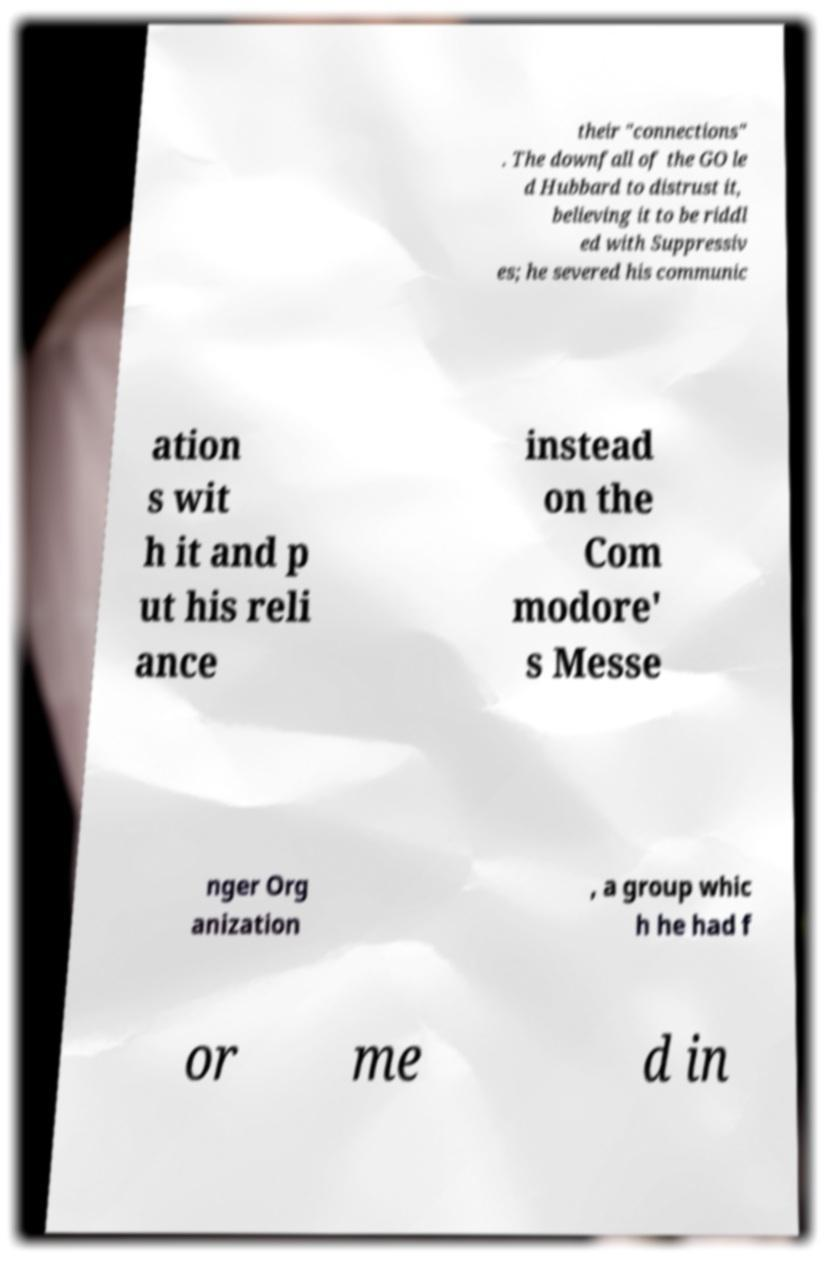For documentation purposes, I need the text within this image transcribed. Could you provide that? their "connections" . The downfall of the GO le d Hubbard to distrust it, believing it to be riddl ed with Suppressiv es; he severed his communic ation s wit h it and p ut his reli ance instead on the Com modore' s Messe nger Org anization , a group whic h he had f or me d in 